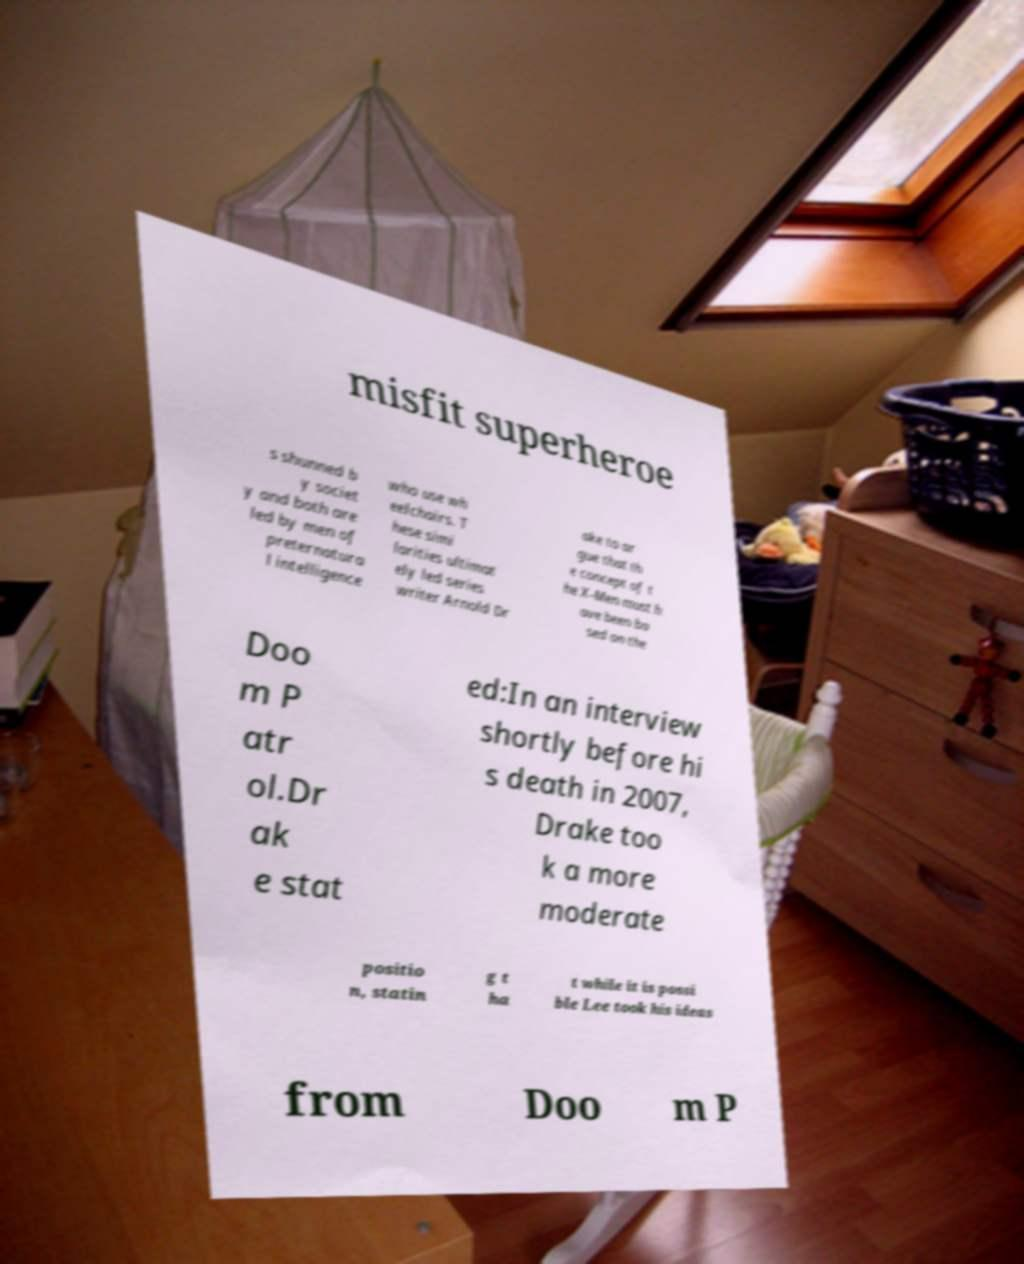Please read and relay the text visible in this image. What does it say? misfit superheroe s shunned b y societ y and both are led by men of preternatura l intelligence who use wh eelchairs. T hese simi larities ultimat ely led series writer Arnold Dr ake to ar gue that th e concept of t he X-Men must h ave been ba sed on the Doo m P atr ol.Dr ak e stat ed:In an interview shortly before hi s death in 2007, Drake too k a more moderate positio n, statin g t ha t while it is possi ble Lee took his ideas from Doo m P 